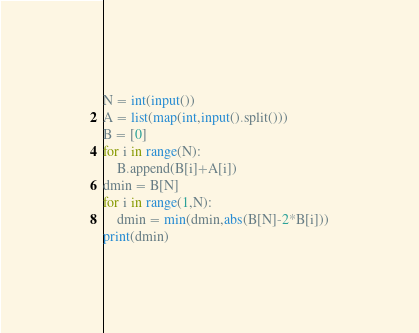<code> <loc_0><loc_0><loc_500><loc_500><_Python_>N = int(input())
A = list(map(int,input().split()))
B = [0]
for i in range(N):
    B.append(B[i]+A[i])
dmin = B[N]
for i in range(1,N):
    dmin = min(dmin,abs(B[N]-2*B[i]))
print(dmin)</code> 